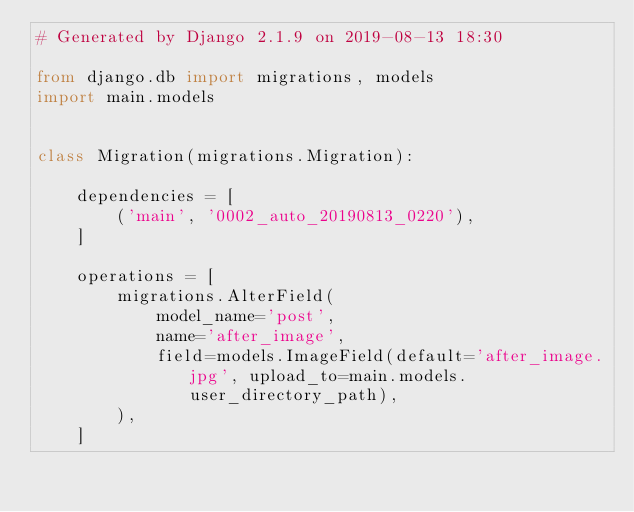<code> <loc_0><loc_0><loc_500><loc_500><_Python_># Generated by Django 2.1.9 on 2019-08-13 18:30

from django.db import migrations, models
import main.models


class Migration(migrations.Migration):

    dependencies = [
        ('main', '0002_auto_20190813_0220'),
    ]

    operations = [
        migrations.AlterField(
            model_name='post',
            name='after_image',
            field=models.ImageField(default='after_image.jpg', upload_to=main.models.user_directory_path),
        ),
    ]
</code> 